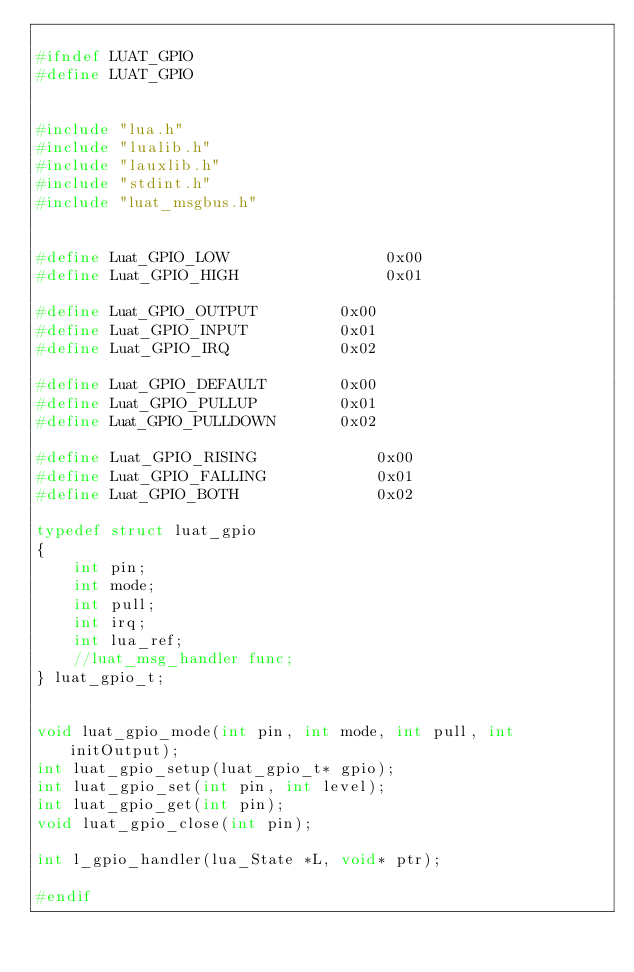Convert code to text. <code><loc_0><loc_0><loc_500><loc_500><_C_>
#ifndef LUAT_GPIO
#define LUAT_GPIO


#include "lua.h"
#include "lualib.h"
#include "lauxlib.h"
#include "stdint.h"
#include "luat_msgbus.h"


#define Luat_GPIO_LOW                 0x00
#define Luat_GPIO_HIGH                0x01

#define Luat_GPIO_OUTPUT         0x00
#define Luat_GPIO_INPUT          0x01
#define Luat_GPIO_IRQ            0x02

#define Luat_GPIO_DEFAULT        0x00
#define Luat_GPIO_PULLUP         0x01
#define Luat_GPIO_PULLDOWN       0x02

#define Luat_GPIO_RISING             0x00
#define Luat_GPIO_FALLING            0x01
#define Luat_GPIO_BOTH               0x02

typedef struct luat_gpio
{
    int pin;
    int mode;
    int pull;
    int irq;
    int lua_ref;
    //luat_msg_handler func;
} luat_gpio_t;


void luat_gpio_mode(int pin, int mode, int pull, int initOutput);
int luat_gpio_setup(luat_gpio_t* gpio);
int luat_gpio_set(int pin, int level);
int luat_gpio_get(int pin);
void luat_gpio_close(int pin);

int l_gpio_handler(lua_State *L, void* ptr);

#endif
</code> 